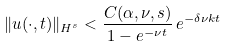Convert formula to latex. <formula><loc_0><loc_0><loc_500><loc_500>\| u ( \cdot , t ) \| _ { H ^ { s } } < \frac { C ( \alpha , \nu , s ) } { 1 - e ^ { - \nu t } } \, e ^ { - \delta \nu k t }</formula> 